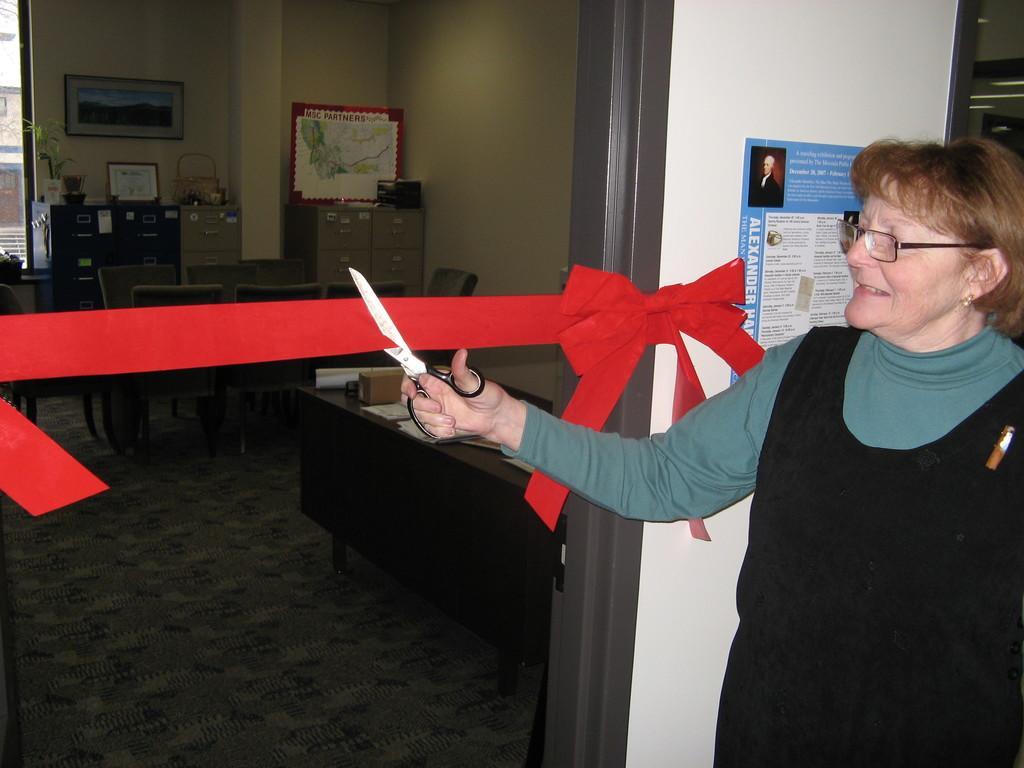How would you summarize this image in a sentence or two? This image is taken indoors. On the right side of the image a woman is standing on the floor and she is cutting a ribbon with a scissor. In the middle of the image there is a wall with a poster on it. At the bottom of the image there is a floor. There are two tables with a few things on them and there are a few empty chairs in the room. There are a few cupboards and a wardrobe. 